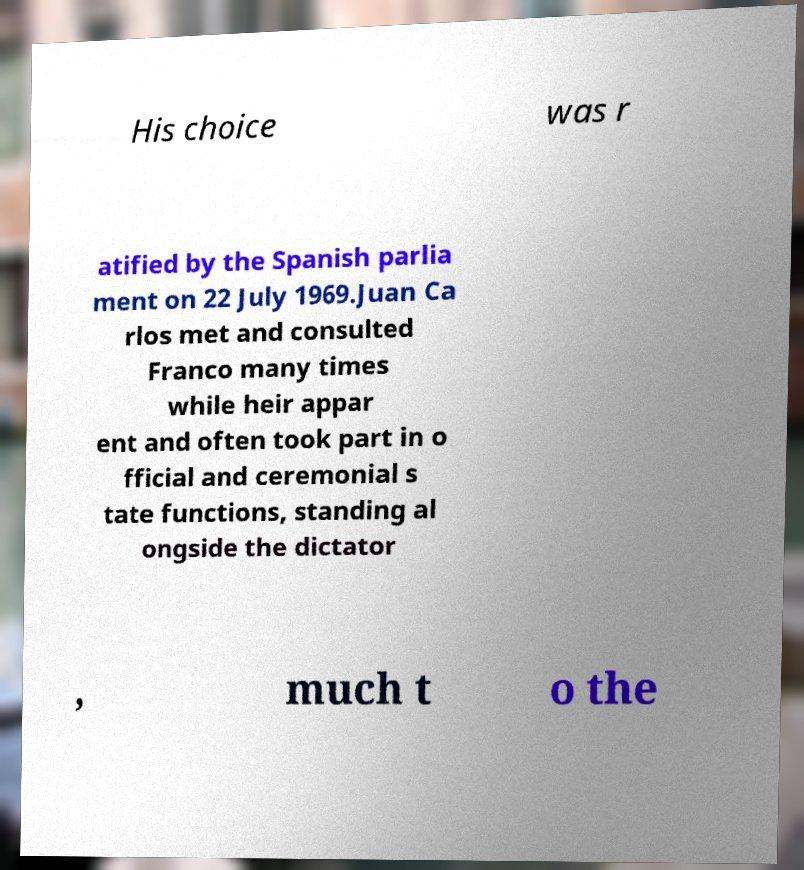Can you read and provide the text displayed in the image?This photo seems to have some interesting text. Can you extract and type it out for me? His choice was r atified by the Spanish parlia ment on 22 July 1969.Juan Ca rlos met and consulted Franco many times while heir appar ent and often took part in o fficial and ceremonial s tate functions, standing al ongside the dictator , much t o the 